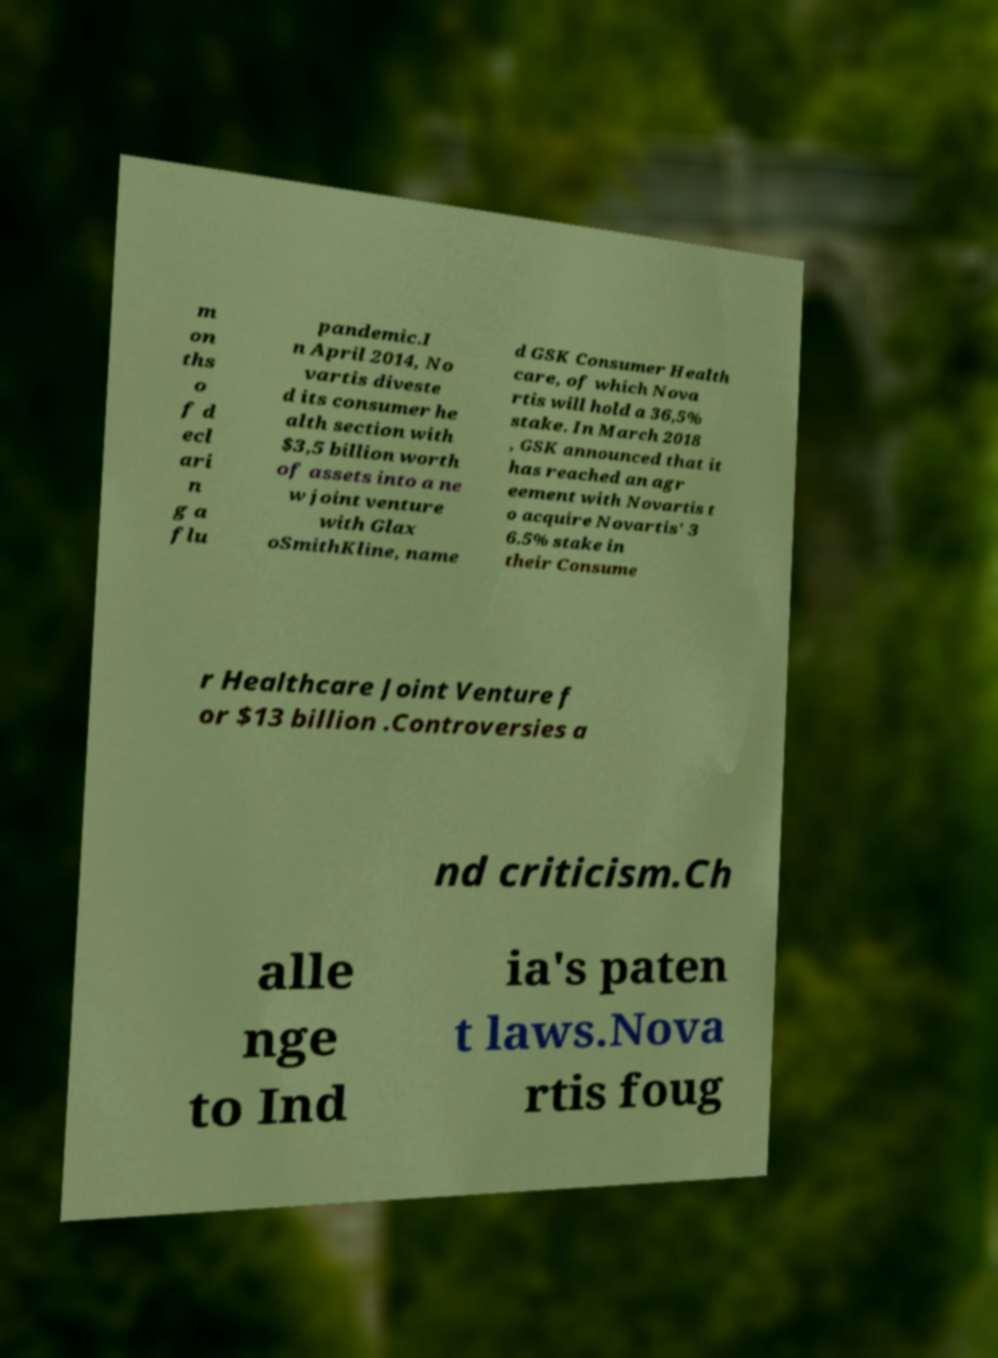What messages or text are displayed in this image? I need them in a readable, typed format. m on ths o f d ecl ari n g a flu pandemic.I n April 2014, No vartis diveste d its consumer he alth section with $3,5 billion worth of assets into a ne w joint venture with Glax oSmithKline, name d GSK Consumer Health care, of which Nova rtis will hold a 36,5% stake. In March 2018 , GSK announced that it has reached an agr eement with Novartis t o acquire Novartis' 3 6.5% stake in their Consume r Healthcare Joint Venture f or $13 billion .Controversies a nd criticism.Ch alle nge to Ind ia's paten t laws.Nova rtis foug 